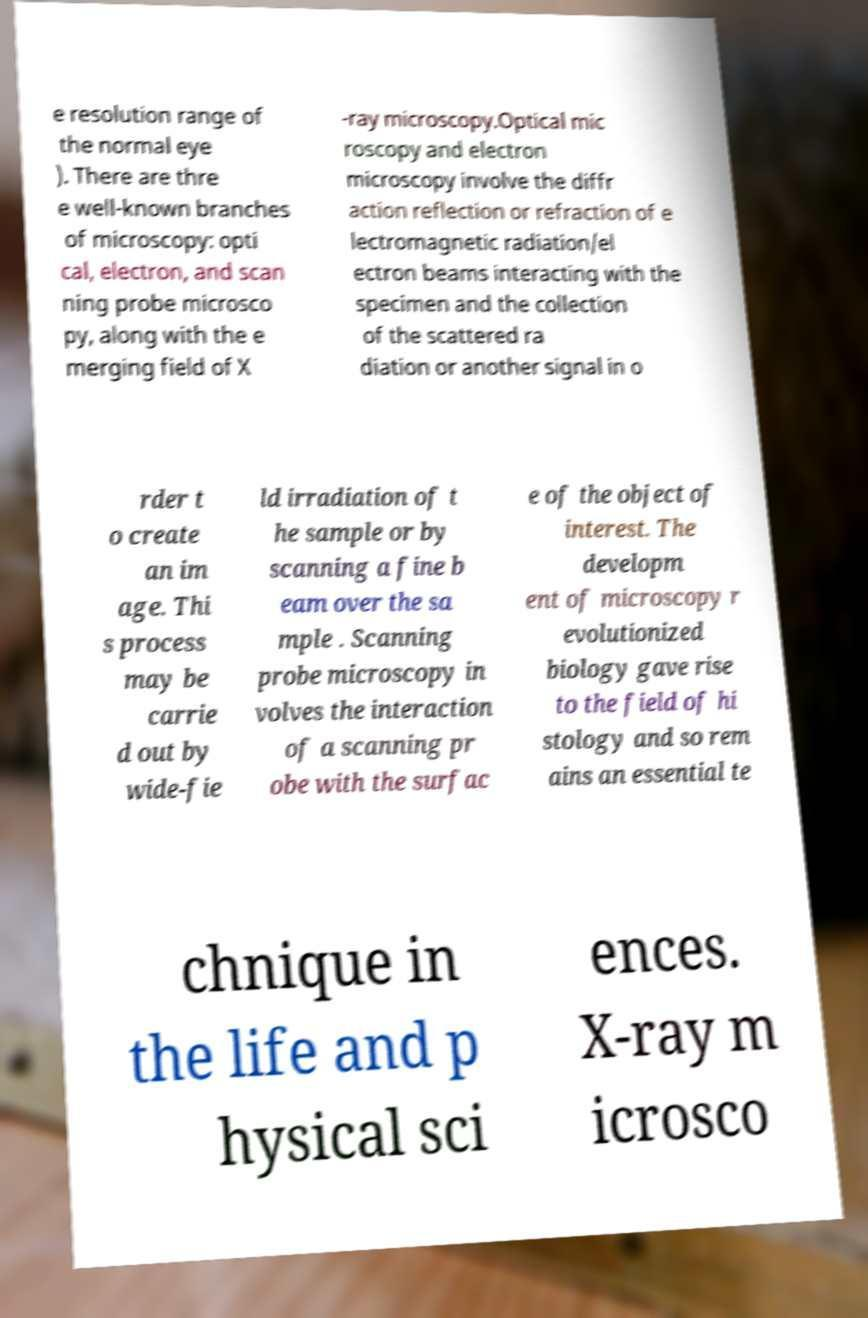Can you accurately transcribe the text from the provided image for me? e resolution range of the normal eye ). There are thre e well-known branches of microscopy: opti cal, electron, and scan ning probe microsco py, along with the e merging field of X -ray microscopy.Optical mic roscopy and electron microscopy involve the diffr action reflection or refraction of e lectromagnetic radiation/el ectron beams interacting with the specimen and the collection of the scattered ra diation or another signal in o rder t o create an im age. Thi s process may be carrie d out by wide-fie ld irradiation of t he sample or by scanning a fine b eam over the sa mple . Scanning probe microscopy in volves the interaction of a scanning pr obe with the surfac e of the object of interest. The developm ent of microscopy r evolutionized biology gave rise to the field of hi stology and so rem ains an essential te chnique in the life and p hysical sci ences. X-ray m icrosco 